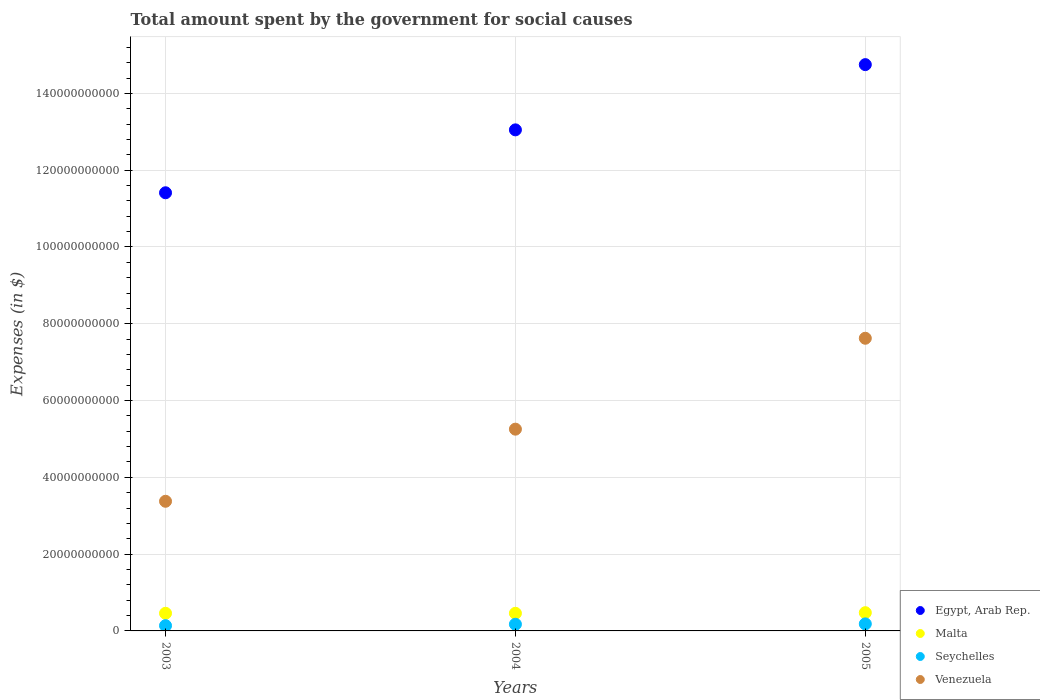How many different coloured dotlines are there?
Offer a very short reply. 4. Is the number of dotlines equal to the number of legend labels?
Your response must be concise. Yes. What is the amount spent for social causes by the government in Egypt, Arab Rep. in 2003?
Give a very brief answer. 1.14e+11. Across all years, what is the maximum amount spent for social causes by the government in Venezuela?
Give a very brief answer. 7.62e+1. Across all years, what is the minimum amount spent for social causes by the government in Seychelles?
Give a very brief answer. 1.37e+09. What is the total amount spent for social causes by the government in Egypt, Arab Rep. in the graph?
Your response must be concise. 3.92e+11. What is the difference between the amount spent for social causes by the government in Seychelles in 2003 and that in 2005?
Offer a terse response. -4.61e+08. What is the difference between the amount spent for social causes by the government in Venezuela in 2003 and the amount spent for social causes by the government in Seychelles in 2005?
Provide a succinct answer. 3.19e+1. What is the average amount spent for social causes by the government in Venezuela per year?
Ensure brevity in your answer.  5.42e+1. In the year 2005, what is the difference between the amount spent for social causes by the government in Malta and amount spent for social causes by the government in Seychelles?
Your answer should be very brief. 2.92e+09. What is the ratio of the amount spent for social causes by the government in Venezuela in 2003 to that in 2004?
Keep it short and to the point. 0.64. Is the difference between the amount spent for social causes by the government in Malta in 2003 and 2005 greater than the difference between the amount spent for social causes by the government in Seychelles in 2003 and 2005?
Your answer should be very brief. Yes. What is the difference between the highest and the second highest amount spent for social causes by the government in Seychelles?
Ensure brevity in your answer.  9.59e+07. What is the difference between the highest and the lowest amount spent for social causes by the government in Seychelles?
Keep it short and to the point. 4.61e+08. Is it the case that in every year, the sum of the amount spent for social causes by the government in Malta and amount spent for social causes by the government in Seychelles  is greater than the sum of amount spent for social causes by the government in Venezuela and amount spent for social causes by the government in Egypt, Arab Rep.?
Provide a short and direct response. Yes. How many dotlines are there?
Your answer should be very brief. 4. What is the difference between two consecutive major ticks on the Y-axis?
Offer a terse response. 2.00e+1. Are the values on the major ticks of Y-axis written in scientific E-notation?
Your answer should be very brief. No. Does the graph contain any zero values?
Provide a short and direct response. No. Does the graph contain grids?
Your response must be concise. Yes. What is the title of the graph?
Your answer should be very brief. Total amount spent by the government for social causes. What is the label or title of the Y-axis?
Give a very brief answer. Expenses (in $). What is the Expenses (in $) of Egypt, Arab Rep. in 2003?
Give a very brief answer. 1.14e+11. What is the Expenses (in $) in Malta in 2003?
Offer a terse response. 4.59e+09. What is the Expenses (in $) of Seychelles in 2003?
Your response must be concise. 1.37e+09. What is the Expenses (in $) in Venezuela in 2003?
Your response must be concise. 3.38e+1. What is the Expenses (in $) of Egypt, Arab Rep. in 2004?
Your answer should be compact. 1.30e+11. What is the Expenses (in $) of Malta in 2004?
Your answer should be compact. 4.59e+09. What is the Expenses (in $) of Seychelles in 2004?
Give a very brief answer. 1.74e+09. What is the Expenses (in $) of Venezuela in 2004?
Make the answer very short. 5.25e+1. What is the Expenses (in $) in Egypt, Arab Rep. in 2005?
Your response must be concise. 1.47e+11. What is the Expenses (in $) of Malta in 2005?
Give a very brief answer. 4.75e+09. What is the Expenses (in $) in Seychelles in 2005?
Your answer should be compact. 1.83e+09. What is the Expenses (in $) in Venezuela in 2005?
Your answer should be very brief. 7.62e+1. Across all years, what is the maximum Expenses (in $) of Egypt, Arab Rep.?
Offer a terse response. 1.47e+11. Across all years, what is the maximum Expenses (in $) of Malta?
Keep it short and to the point. 4.75e+09. Across all years, what is the maximum Expenses (in $) of Seychelles?
Provide a short and direct response. 1.83e+09. Across all years, what is the maximum Expenses (in $) of Venezuela?
Offer a terse response. 7.62e+1. Across all years, what is the minimum Expenses (in $) in Egypt, Arab Rep.?
Ensure brevity in your answer.  1.14e+11. Across all years, what is the minimum Expenses (in $) of Malta?
Your answer should be very brief. 4.59e+09. Across all years, what is the minimum Expenses (in $) of Seychelles?
Offer a very short reply. 1.37e+09. Across all years, what is the minimum Expenses (in $) in Venezuela?
Your answer should be compact. 3.38e+1. What is the total Expenses (in $) in Egypt, Arab Rep. in the graph?
Give a very brief answer. 3.92e+11. What is the total Expenses (in $) in Malta in the graph?
Make the answer very short. 1.39e+1. What is the total Expenses (in $) in Seychelles in the graph?
Provide a short and direct response. 4.94e+09. What is the total Expenses (in $) in Venezuela in the graph?
Offer a very short reply. 1.63e+11. What is the difference between the Expenses (in $) in Egypt, Arab Rep. in 2003 and that in 2004?
Your answer should be very brief. -1.64e+1. What is the difference between the Expenses (in $) of Malta in 2003 and that in 2004?
Provide a short and direct response. 1.82e+06. What is the difference between the Expenses (in $) in Seychelles in 2003 and that in 2004?
Keep it short and to the point. -3.65e+08. What is the difference between the Expenses (in $) in Venezuela in 2003 and that in 2004?
Give a very brief answer. -1.88e+1. What is the difference between the Expenses (in $) in Egypt, Arab Rep. in 2003 and that in 2005?
Give a very brief answer. -3.34e+1. What is the difference between the Expenses (in $) in Malta in 2003 and that in 2005?
Keep it short and to the point. -1.55e+08. What is the difference between the Expenses (in $) of Seychelles in 2003 and that in 2005?
Offer a terse response. -4.61e+08. What is the difference between the Expenses (in $) of Venezuela in 2003 and that in 2005?
Ensure brevity in your answer.  -4.25e+1. What is the difference between the Expenses (in $) in Egypt, Arab Rep. in 2004 and that in 2005?
Provide a short and direct response. -1.70e+1. What is the difference between the Expenses (in $) of Malta in 2004 and that in 2005?
Ensure brevity in your answer.  -1.56e+08. What is the difference between the Expenses (in $) in Seychelles in 2004 and that in 2005?
Offer a terse response. -9.59e+07. What is the difference between the Expenses (in $) in Venezuela in 2004 and that in 2005?
Make the answer very short. -2.37e+1. What is the difference between the Expenses (in $) in Egypt, Arab Rep. in 2003 and the Expenses (in $) in Malta in 2004?
Your answer should be compact. 1.10e+11. What is the difference between the Expenses (in $) of Egypt, Arab Rep. in 2003 and the Expenses (in $) of Seychelles in 2004?
Provide a succinct answer. 1.12e+11. What is the difference between the Expenses (in $) in Egypt, Arab Rep. in 2003 and the Expenses (in $) in Venezuela in 2004?
Ensure brevity in your answer.  6.16e+1. What is the difference between the Expenses (in $) of Malta in 2003 and the Expenses (in $) of Seychelles in 2004?
Provide a short and direct response. 2.86e+09. What is the difference between the Expenses (in $) of Malta in 2003 and the Expenses (in $) of Venezuela in 2004?
Your response must be concise. -4.80e+1. What is the difference between the Expenses (in $) of Seychelles in 2003 and the Expenses (in $) of Venezuela in 2004?
Provide a short and direct response. -5.12e+1. What is the difference between the Expenses (in $) in Egypt, Arab Rep. in 2003 and the Expenses (in $) in Malta in 2005?
Offer a very short reply. 1.09e+11. What is the difference between the Expenses (in $) of Egypt, Arab Rep. in 2003 and the Expenses (in $) of Seychelles in 2005?
Make the answer very short. 1.12e+11. What is the difference between the Expenses (in $) of Egypt, Arab Rep. in 2003 and the Expenses (in $) of Venezuela in 2005?
Your answer should be compact. 3.79e+1. What is the difference between the Expenses (in $) of Malta in 2003 and the Expenses (in $) of Seychelles in 2005?
Offer a very short reply. 2.76e+09. What is the difference between the Expenses (in $) of Malta in 2003 and the Expenses (in $) of Venezuela in 2005?
Provide a short and direct response. -7.16e+1. What is the difference between the Expenses (in $) of Seychelles in 2003 and the Expenses (in $) of Venezuela in 2005?
Make the answer very short. -7.49e+1. What is the difference between the Expenses (in $) of Egypt, Arab Rep. in 2004 and the Expenses (in $) of Malta in 2005?
Offer a terse response. 1.26e+11. What is the difference between the Expenses (in $) of Egypt, Arab Rep. in 2004 and the Expenses (in $) of Seychelles in 2005?
Keep it short and to the point. 1.29e+11. What is the difference between the Expenses (in $) of Egypt, Arab Rep. in 2004 and the Expenses (in $) of Venezuela in 2005?
Your answer should be very brief. 5.43e+1. What is the difference between the Expenses (in $) of Malta in 2004 and the Expenses (in $) of Seychelles in 2005?
Your answer should be very brief. 2.76e+09. What is the difference between the Expenses (in $) in Malta in 2004 and the Expenses (in $) in Venezuela in 2005?
Provide a short and direct response. -7.16e+1. What is the difference between the Expenses (in $) of Seychelles in 2004 and the Expenses (in $) of Venezuela in 2005?
Offer a very short reply. -7.45e+1. What is the average Expenses (in $) in Egypt, Arab Rep. per year?
Make the answer very short. 1.31e+11. What is the average Expenses (in $) of Malta per year?
Offer a terse response. 4.65e+09. What is the average Expenses (in $) in Seychelles per year?
Offer a terse response. 1.65e+09. What is the average Expenses (in $) of Venezuela per year?
Give a very brief answer. 5.42e+1. In the year 2003, what is the difference between the Expenses (in $) in Egypt, Arab Rep. and Expenses (in $) in Malta?
Give a very brief answer. 1.10e+11. In the year 2003, what is the difference between the Expenses (in $) of Egypt, Arab Rep. and Expenses (in $) of Seychelles?
Make the answer very short. 1.13e+11. In the year 2003, what is the difference between the Expenses (in $) in Egypt, Arab Rep. and Expenses (in $) in Venezuela?
Ensure brevity in your answer.  8.03e+1. In the year 2003, what is the difference between the Expenses (in $) of Malta and Expenses (in $) of Seychelles?
Provide a succinct answer. 3.22e+09. In the year 2003, what is the difference between the Expenses (in $) in Malta and Expenses (in $) in Venezuela?
Provide a short and direct response. -2.92e+1. In the year 2003, what is the difference between the Expenses (in $) in Seychelles and Expenses (in $) in Venezuela?
Provide a succinct answer. -3.24e+1. In the year 2004, what is the difference between the Expenses (in $) of Egypt, Arab Rep. and Expenses (in $) of Malta?
Provide a short and direct response. 1.26e+11. In the year 2004, what is the difference between the Expenses (in $) in Egypt, Arab Rep. and Expenses (in $) in Seychelles?
Your answer should be compact. 1.29e+11. In the year 2004, what is the difference between the Expenses (in $) in Egypt, Arab Rep. and Expenses (in $) in Venezuela?
Offer a terse response. 7.80e+1. In the year 2004, what is the difference between the Expenses (in $) in Malta and Expenses (in $) in Seychelles?
Provide a succinct answer. 2.86e+09. In the year 2004, what is the difference between the Expenses (in $) of Malta and Expenses (in $) of Venezuela?
Make the answer very short. -4.80e+1. In the year 2004, what is the difference between the Expenses (in $) in Seychelles and Expenses (in $) in Venezuela?
Make the answer very short. -5.08e+1. In the year 2005, what is the difference between the Expenses (in $) in Egypt, Arab Rep. and Expenses (in $) in Malta?
Provide a succinct answer. 1.43e+11. In the year 2005, what is the difference between the Expenses (in $) of Egypt, Arab Rep. and Expenses (in $) of Seychelles?
Your response must be concise. 1.46e+11. In the year 2005, what is the difference between the Expenses (in $) in Egypt, Arab Rep. and Expenses (in $) in Venezuela?
Offer a terse response. 7.13e+1. In the year 2005, what is the difference between the Expenses (in $) of Malta and Expenses (in $) of Seychelles?
Your response must be concise. 2.92e+09. In the year 2005, what is the difference between the Expenses (in $) in Malta and Expenses (in $) in Venezuela?
Your answer should be very brief. -7.15e+1. In the year 2005, what is the difference between the Expenses (in $) of Seychelles and Expenses (in $) of Venezuela?
Your answer should be compact. -7.44e+1. What is the ratio of the Expenses (in $) in Egypt, Arab Rep. in 2003 to that in 2004?
Offer a very short reply. 0.87. What is the ratio of the Expenses (in $) in Malta in 2003 to that in 2004?
Provide a succinct answer. 1. What is the ratio of the Expenses (in $) in Seychelles in 2003 to that in 2004?
Give a very brief answer. 0.79. What is the ratio of the Expenses (in $) of Venezuela in 2003 to that in 2004?
Provide a short and direct response. 0.64. What is the ratio of the Expenses (in $) of Egypt, Arab Rep. in 2003 to that in 2005?
Your response must be concise. 0.77. What is the ratio of the Expenses (in $) of Malta in 2003 to that in 2005?
Your answer should be very brief. 0.97. What is the ratio of the Expenses (in $) in Seychelles in 2003 to that in 2005?
Offer a terse response. 0.75. What is the ratio of the Expenses (in $) of Venezuela in 2003 to that in 2005?
Your answer should be very brief. 0.44. What is the ratio of the Expenses (in $) in Egypt, Arab Rep. in 2004 to that in 2005?
Provide a succinct answer. 0.88. What is the ratio of the Expenses (in $) in Malta in 2004 to that in 2005?
Your response must be concise. 0.97. What is the ratio of the Expenses (in $) in Seychelles in 2004 to that in 2005?
Give a very brief answer. 0.95. What is the ratio of the Expenses (in $) in Venezuela in 2004 to that in 2005?
Keep it short and to the point. 0.69. What is the difference between the highest and the second highest Expenses (in $) of Egypt, Arab Rep.?
Your response must be concise. 1.70e+1. What is the difference between the highest and the second highest Expenses (in $) in Malta?
Ensure brevity in your answer.  1.55e+08. What is the difference between the highest and the second highest Expenses (in $) in Seychelles?
Your answer should be very brief. 9.59e+07. What is the difference between the highest and the second highest Expenses (in $) in Venezuela?
Your answer should be compact. 2.37e+1. What is the difference between the highest and the lowest Expenses (in $) in Egypt, Arab Rep.?
Offer a very short reply. 3.34e+1. What is the difference between the highest and the lowest Expenses (in $) in Malta?
Your answer should be very brief. 1.56e+08. What is the difference between the highest and the lowest Expenses (in $) in Seychelles?
Your response must be concise. 4.61e+08. What is the difference between the highest and the lowest Expenses (in $) in Venezuela?
Your answer should be very brief. 4.25e+1. 